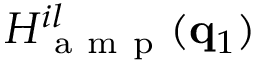Convert formula to latex. <formula><loc_0><loc_0><loc_500><loc_500>H _ { a m p } ^ { i l } ( q _ { 1 } )</formula> 